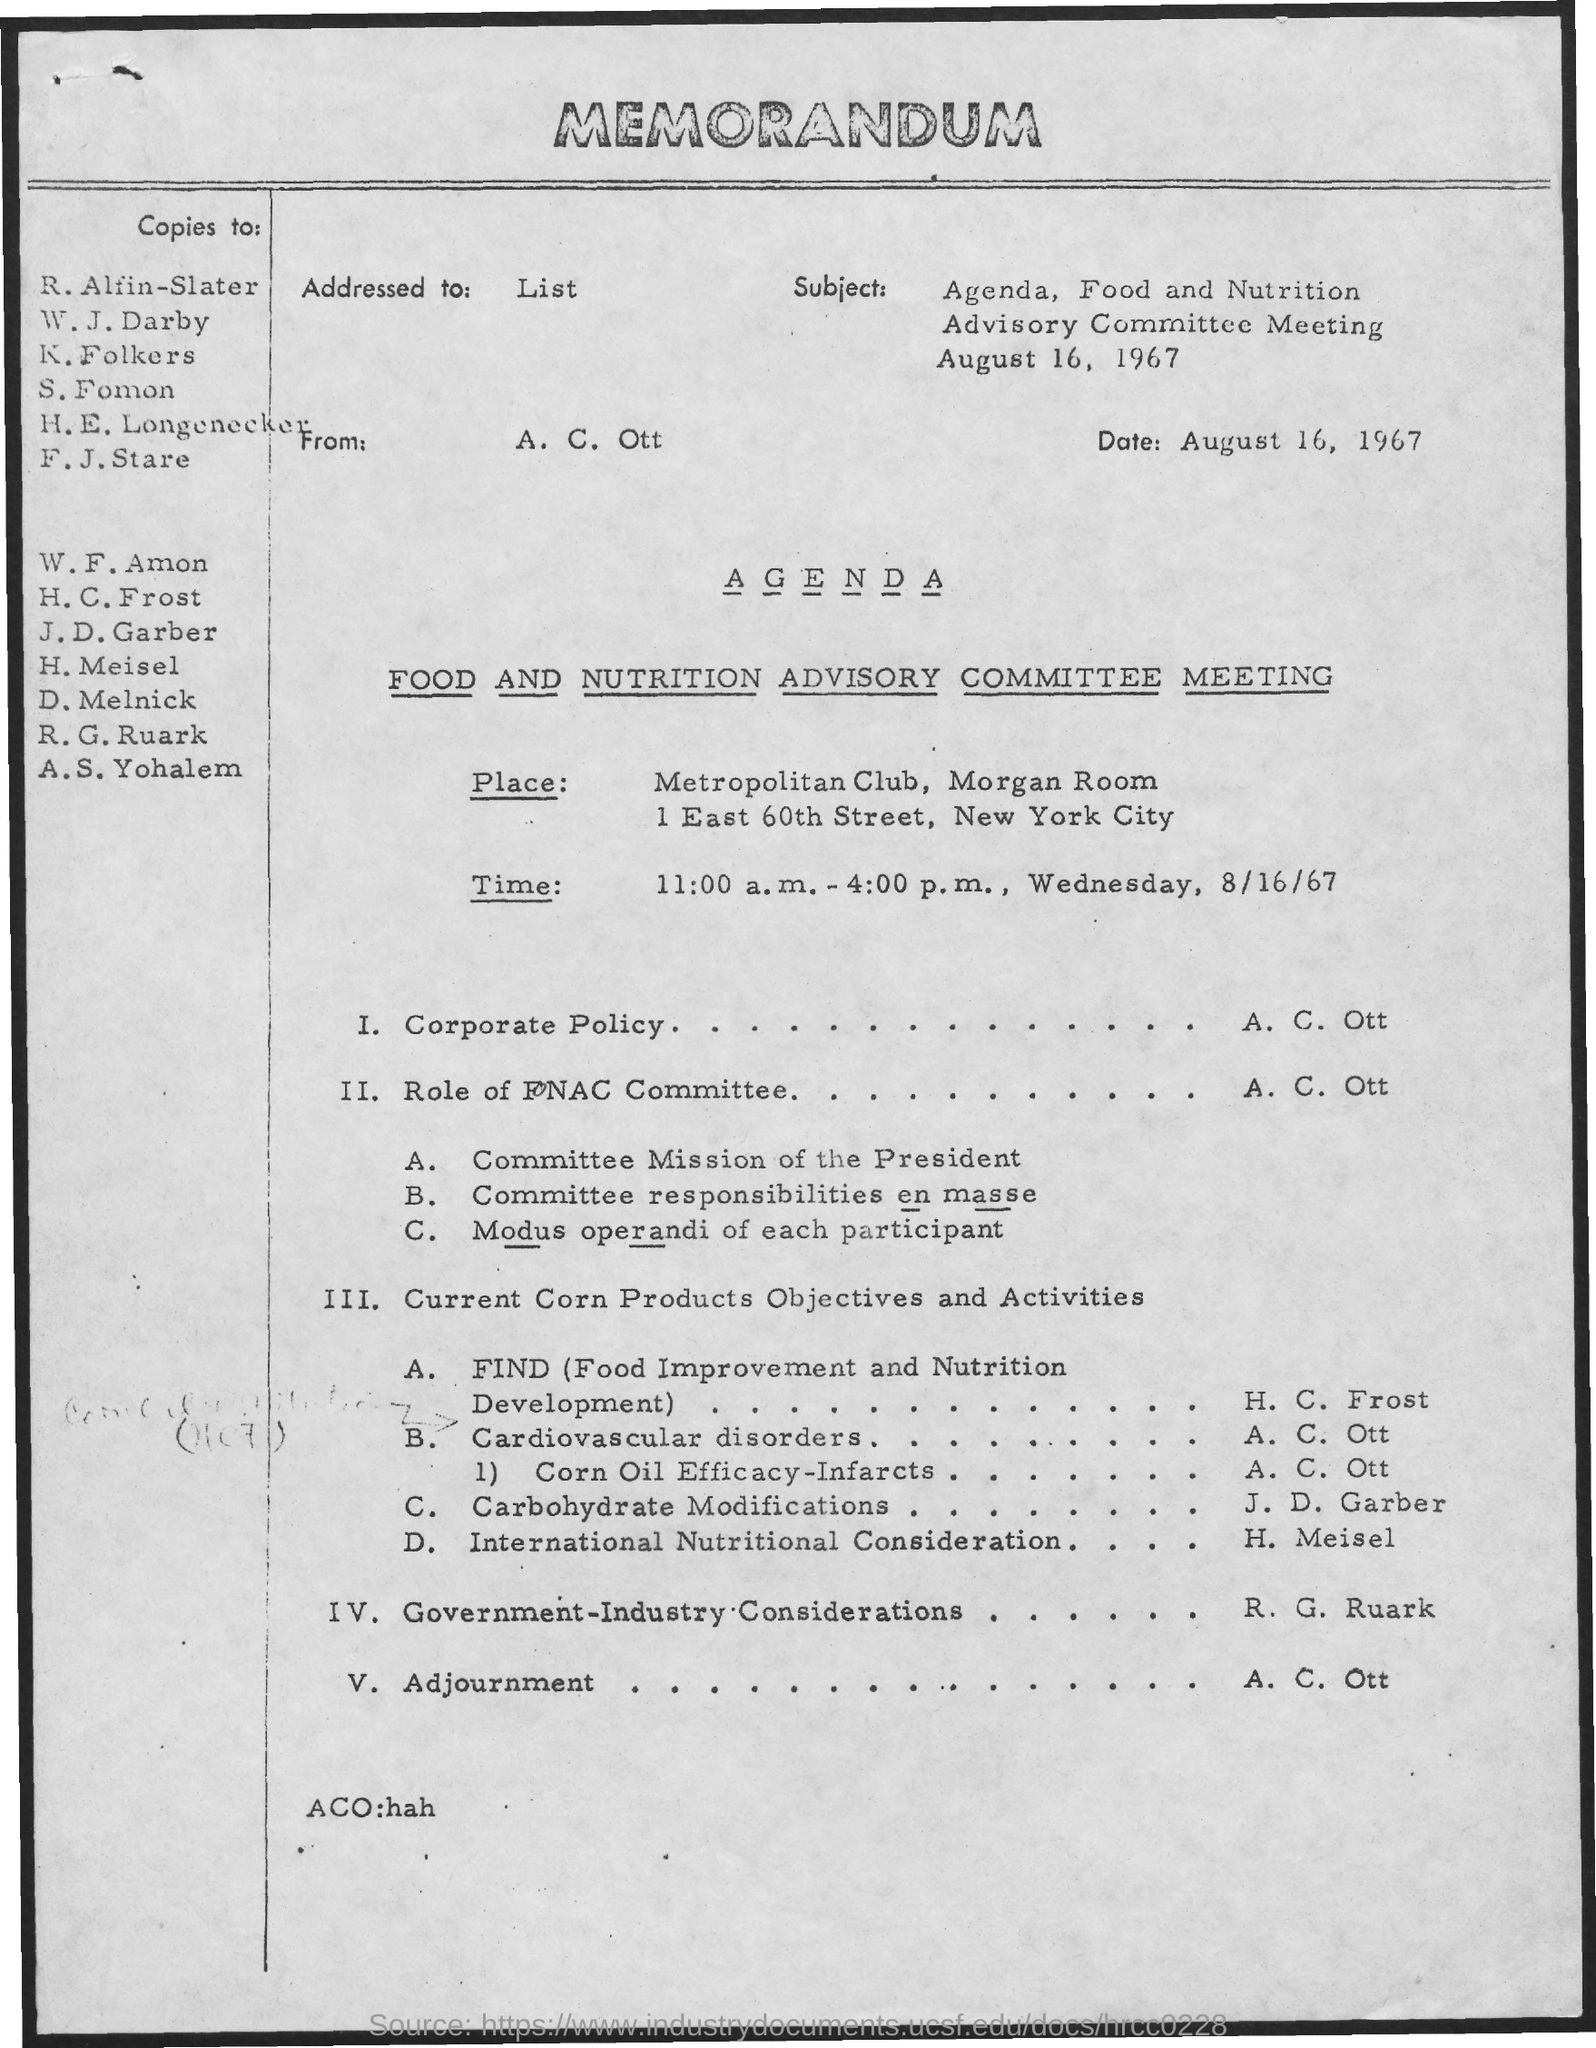Highlight a few significant elements in this photo. The meeting will be held at the Metropolitan Club, in the Morgan Room. The subject mentioned in the given memorandum is the Agenda for the Food and Nutrition Advisory Committee meeting that took place on August 16, 1967. The date mentioned in the given memorandum is August 16, 1967. The name of the meeting mentioned in the given agenda is the Food and Nutrition Advisory Committee Meeting. The scheduled time for the given meeting is from 11:00 a.m. to 4:00 p.m. 